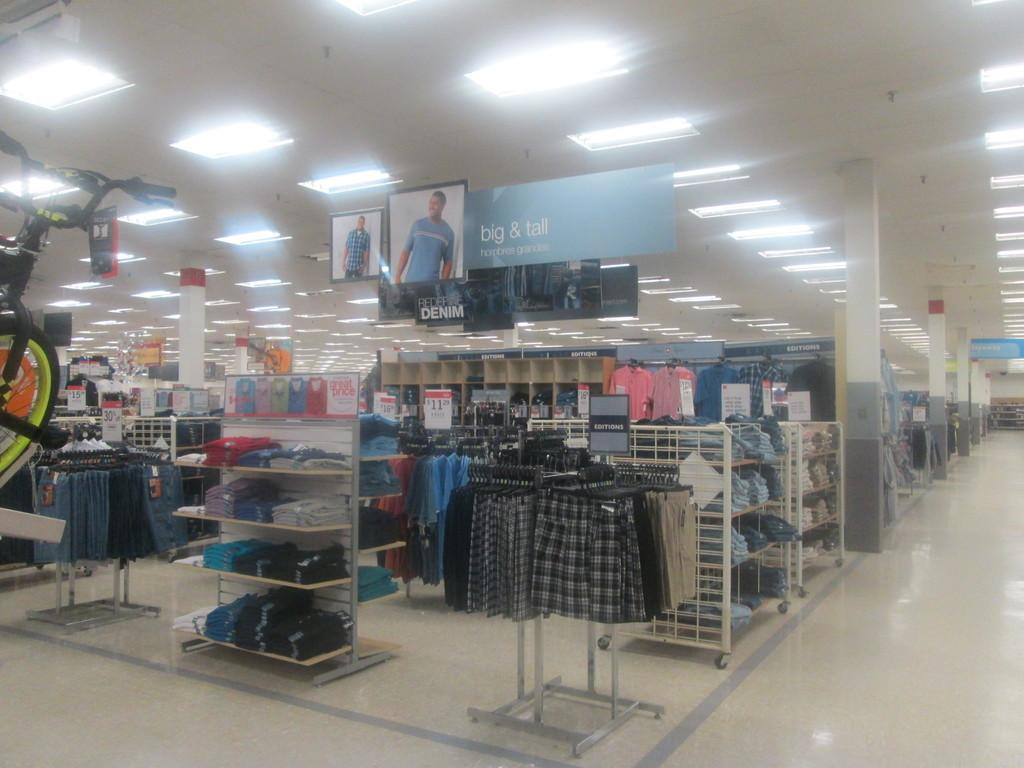<image>
Describe the image concisely. A sign that says Big and Tall hangs above the men's section of the store 